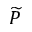Convert formula to latex. <formula><loc_0><loc_0><loc_500><loc_500>\widetilde { P }</formula> 